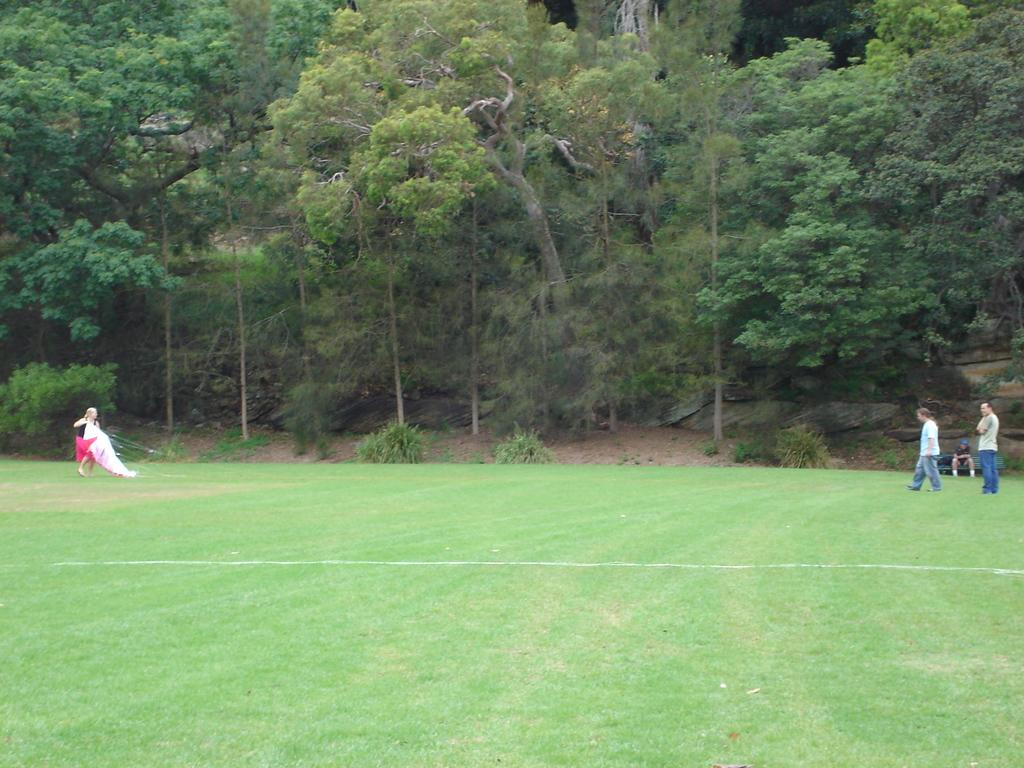What is the person in the image holding? The person is holding a kite. How many people are standing in the image? There are two persons standing in the image. What is the position of the third person in the image? The third person is sitting. What can be seen in the background of the image? Trees are visible in the background of the image. What type of zinc is present in the image? There is no zinc present in the image. How does the person holding the kite feel in the image? The image does not convey the feelings of the person holding the kite, so it cannot be determined from the image. 